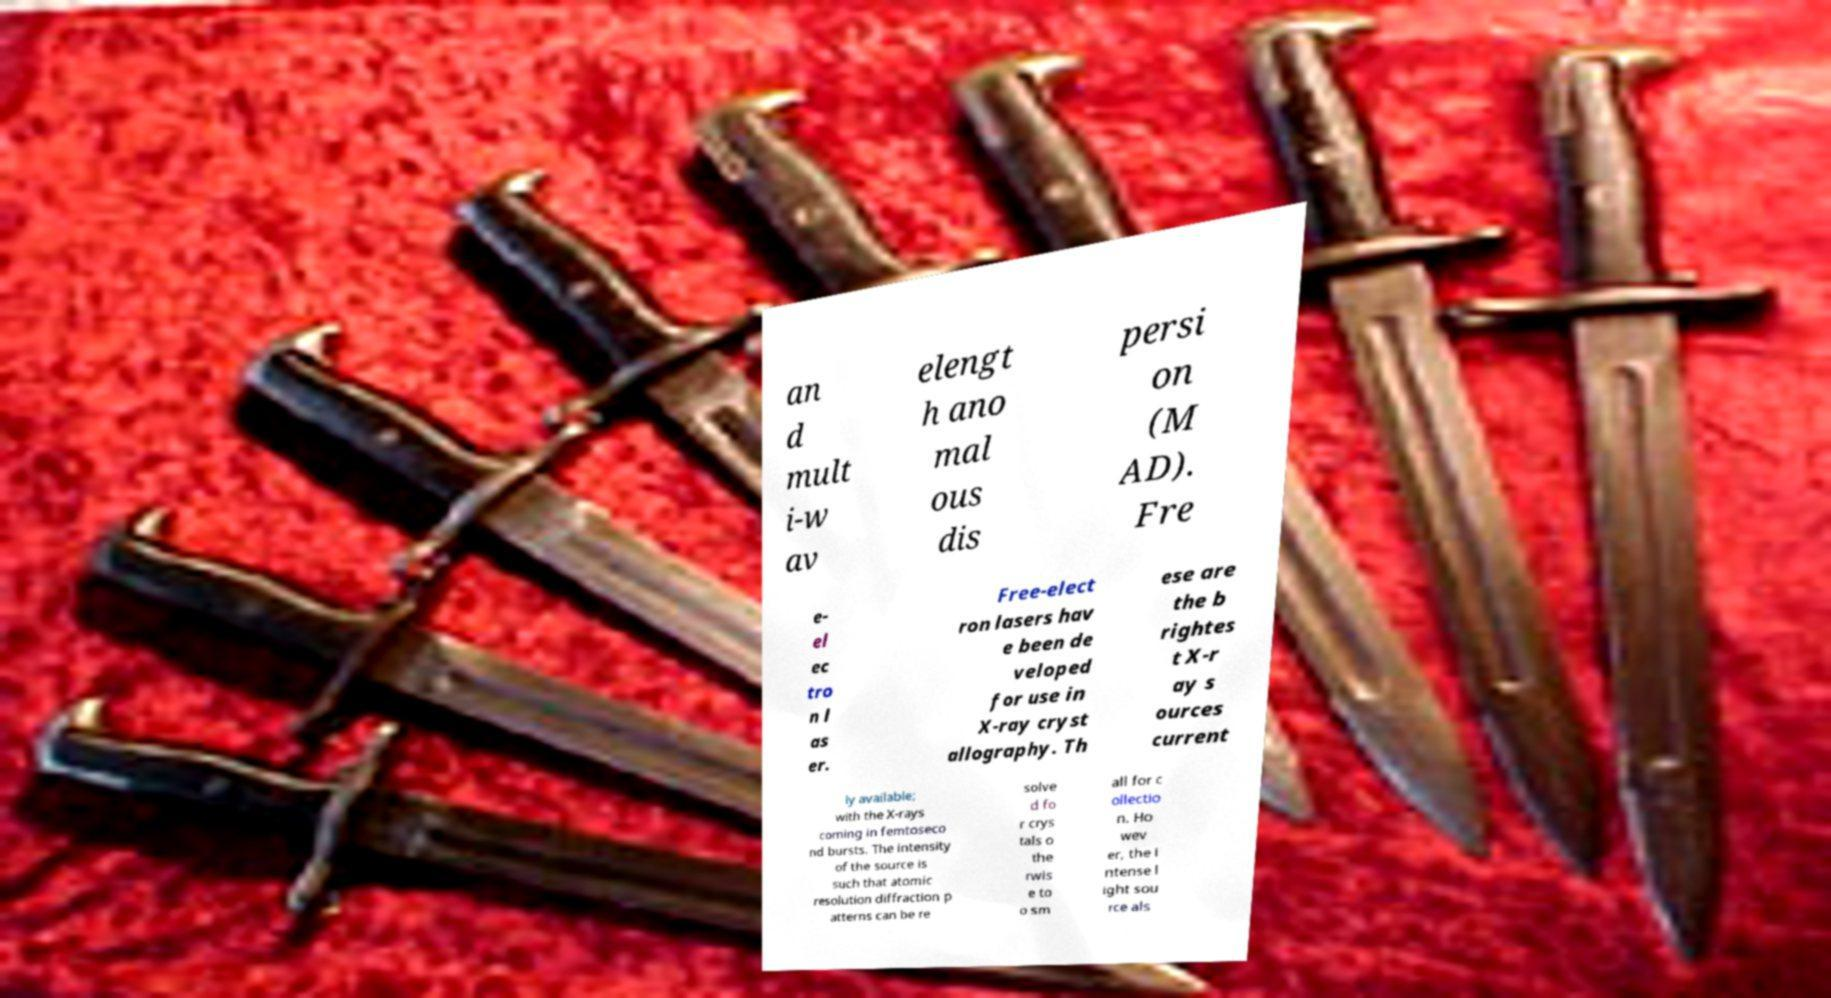Can you accurately transcribe the text from the provided image for me? an d mult i-w av elengt h ano mal ous dis persi on (M AD). Fre e- el ec tro n l as er. Free-elect ron lasers hav e been de veloped for use in X-ray cryst allography. Th ese are the b rightes t X-r ay s ources current ly available; with the X-rays coming in femtoseco nd bursts. The intensity of the source is such that atomic resolution diffraction p atterns can be re solve d fo r crys tals o the rwis e to o sm all for c ollectio n. Ho wev er, the i ntense l ight sou rce als 